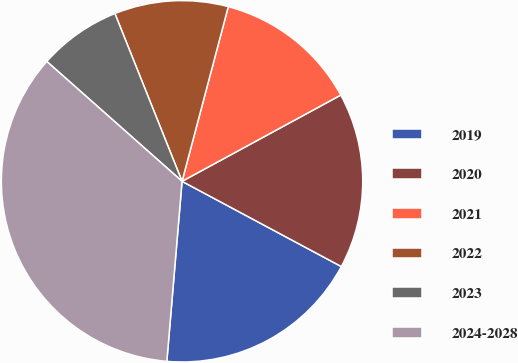Convert chart. <chart><loc_0><loc_0><loc_500><loc_500><pie_chart><fcel>2019<fcel>2020<fcel>2021<fcel>2022<fcel>2023<fcel>2024-2028<nl><fcel>18.52%<fcel>15.74%<fcel>12.96%<fcel>10.18%<fcel>7.4%<fcel>35.2%<nl></chart> 